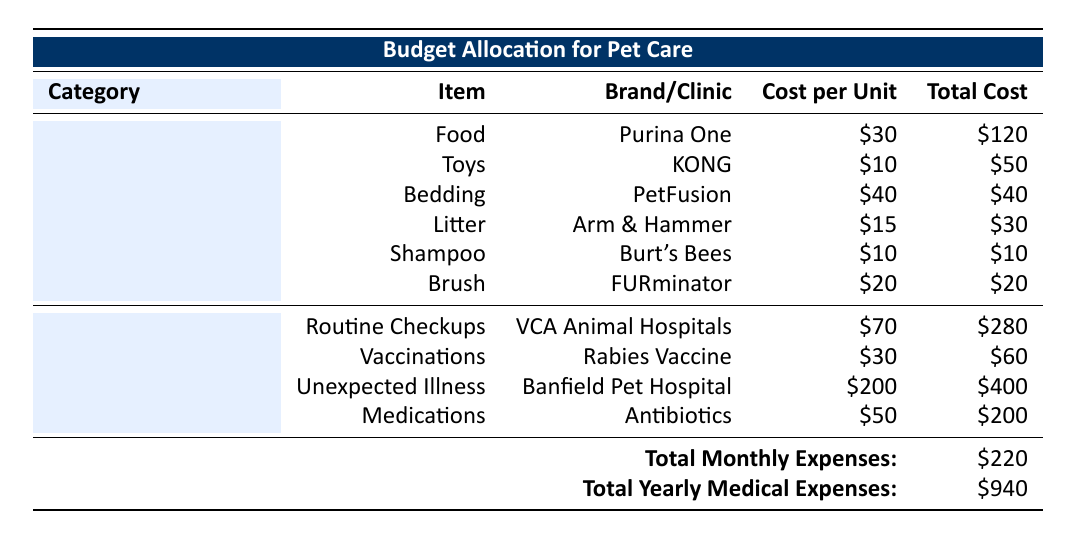What is the total cost for food each month? The table shows that the cost per unit for food (Purina One) is 30, and there are 4 units purchased per month. Therefore, the total cost is calculated as 30 * 4 = 120.
Answer: 120 How much does the KONG toy cost in total for a month? The cost per unit for the KONG toy is 10, and 5 units are bought each month. The total cost is calculated by multiplying the cost per unit by the number of units: 10 * 5 = 50.
Answer: 50 What is the total amount allocated for medical emergencies in a year? The table lists the total yearly medical expenses as 940, which comprises all individual medical costs, including routine checkups, vaccinations, unexpected illness, and medications.
Answer: 940 Is the cost of medication for antibiotics more or less than the cost of routine checkups? The cost for antibiotics is 200 (4 prescriptions at 50 each), while the cost for routine checkups is 280 (4 visits at 70 each). Since 200 is less than 280, the statement is true.
Answer: Yes What is the total monthly expenditure for pet supplies? To find the total monthly expenditure for pet supplies, we add the costs of food (120), toys (50), bedding (40), litter (30), shampoo (10), and brush (20). The total is 120 + 50 + 40 + 30 + 10 + 20 = 270.
Answer: 270 What is the total cost of vaccinations for a year? The annual cost for vaccinations is detailed with the rabies vaccine priced at 30 per shot and 2 shots required per year. Thus, the total cost for vaccinations is calculated as 30 * 2 = 60.
Answer: 60 How much do you spend on pet supplies compared to medical emergencies monthly? Monthly pet supplies cost 270, whereas monthly medical expenses amount to 220. Calculating the difference shows that pet supplies exceed medical emergencies by 270 - 220 = 50.
Answer: 50 Which brand is used for pet grooming shampoo, and how much does it cost? The table lists the pet grooming shampoo brand as Burt's Bees, with a cost of 10 per unit.
Answer: Burt's Bees, 10 What is the average cost per medical expense incident throughout the year? To find the average, we total all medical expenses: 280 (checkups) + 60 (vaccinations) + 400 (unexpected illness) + 200 (medications) = 940, and since there are 4 types of expenses, the average is 940 / 4 = 235.
Answer: 235 